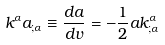<formula> <loc_0><loc_0><loc_500><loc_500>k ^ { \alpha } a _ { ; \alpha } \equiv \frac { d a } { d v } = - \frac { 1 } { 2 } a k ^ { \alpha } _ { ; \alpha }</formula> 